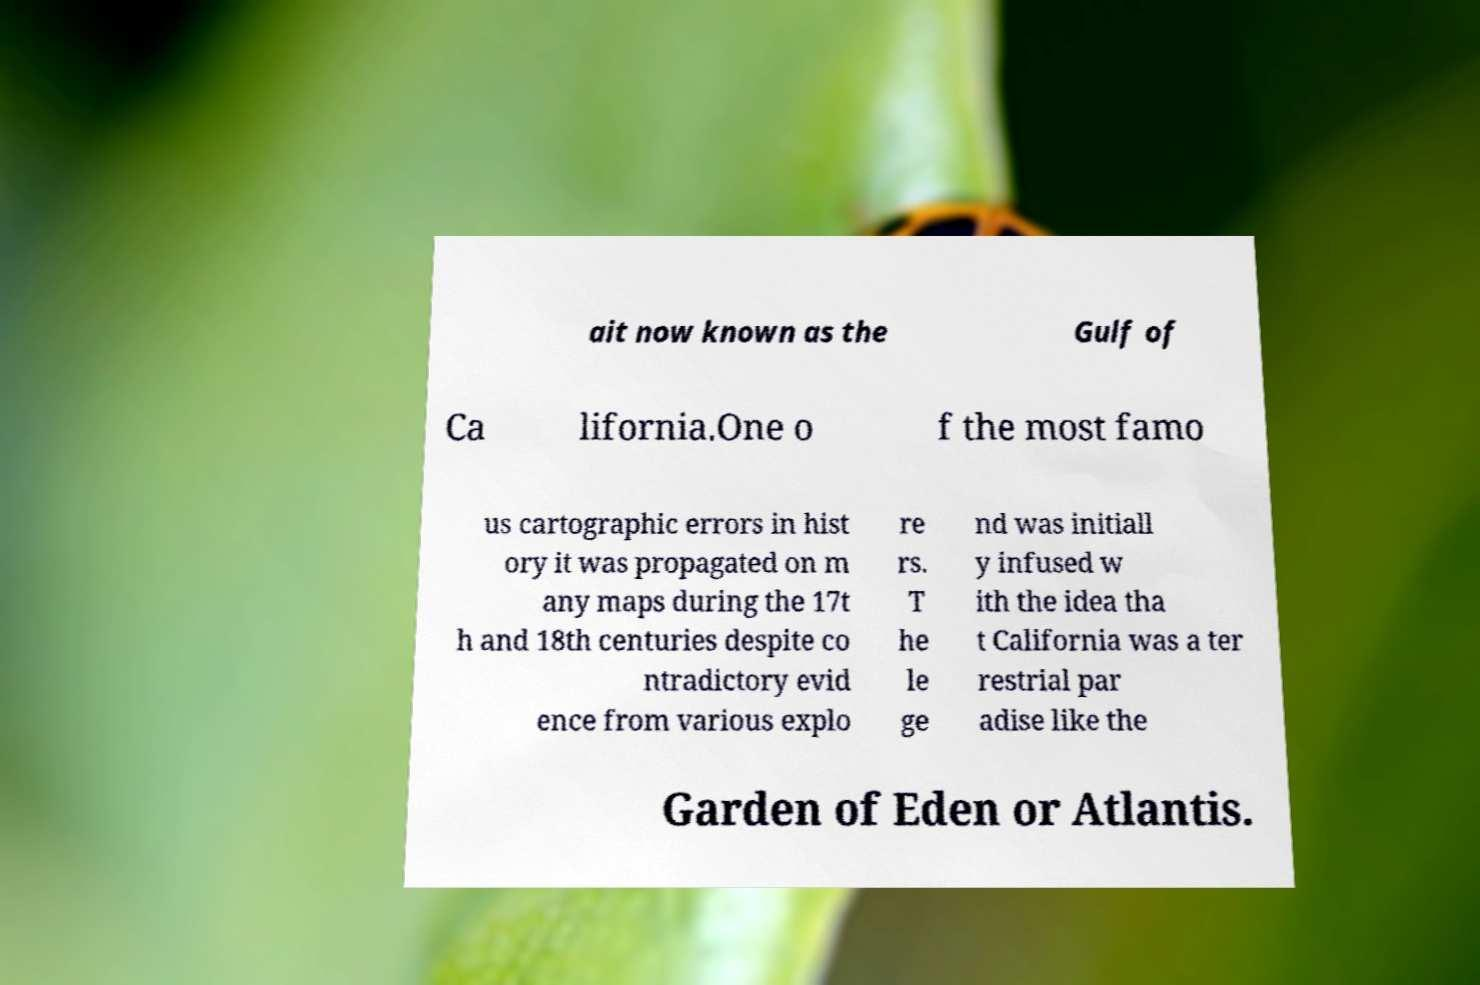There's text embedded in this image that I need extracted. Can you transcribe it verbatim? ait now known as the Gulf of Ca lifornia.One o f the most famo us cartographic errors in hist ory it was propagated on m any maps during the 17t h and 18th centuries despite co ntradictory evid ence from various explo re rs. T he le ge nd was initiall y infused w ith the idea tha t California was a ter restrial par adise like the Garden of Eden or Atlantis. 